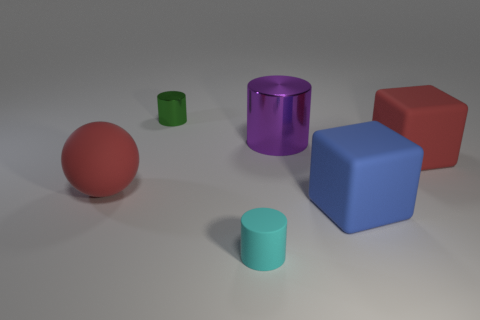Does the large rubber sphere have the same color as the tiny object that is behind the big metal object?
Make the answer very short. No. Is the number of blue things left of the large red ball the same as the number of blue rubber objects in front of the tiny cyan thing?
Your answer should be very brief. Yes. What number of tiny green metallic things have the same shape as the tiny cyan matte thing?
Provide a succinct answer. 1. Are any green spheres visible?
Give a very brief answer. No. Do the big blue object and the tiny object that is behind the large ball have the same material?
Your response must be concise. No. There is a red block that is the same size as the rubber sphere; what material is it?
Keep it short and to the point. Rubber. Are there any tiny green objects made of the same material as the blue thing?
Keep it short and to the point. No. Is there a matte cylinder that is in front of the small cylinder that is behind the large object on the left side of the cyan matte thing?
Keep it short and to the point. Yes. What shape is the cyan object that is the same size as the green metallic cylinder?
Keep it short and to the point. Cylinder. Does the cylinder right of the small matte thing have the same size as the cylinder behind the purple metal object?
Provide a short and direct response. No. 